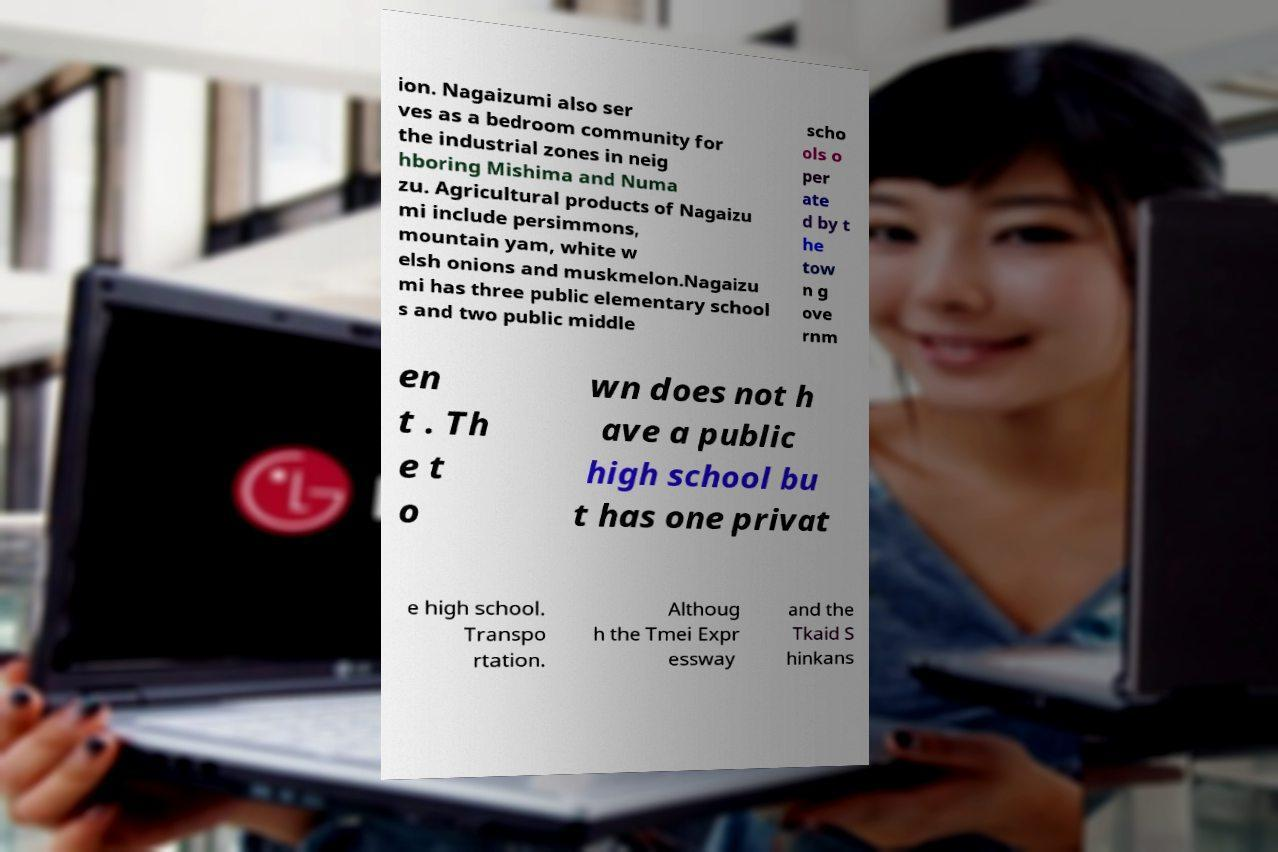What messages or text are displayed in this image? I need them in a readable, typed format. ion. Nagaizumi also ser ves as a bedroom community for the industrial zones in neig hboring Mishima and Numa zu. Agricultural products of Nagaizu mi include persimmons, mountain yam, white w elsh onions and muskmelon.Nagaizu mi has three public elementary school s and two public middle scho ols o per ate d by t he tow n g ove rnm en t . Th e t o wn does not h ave a public high school bu t has one privat e high school. Transpo rtation. Althoug h the Tmei Expr essway and the Tkaid S hinkans 